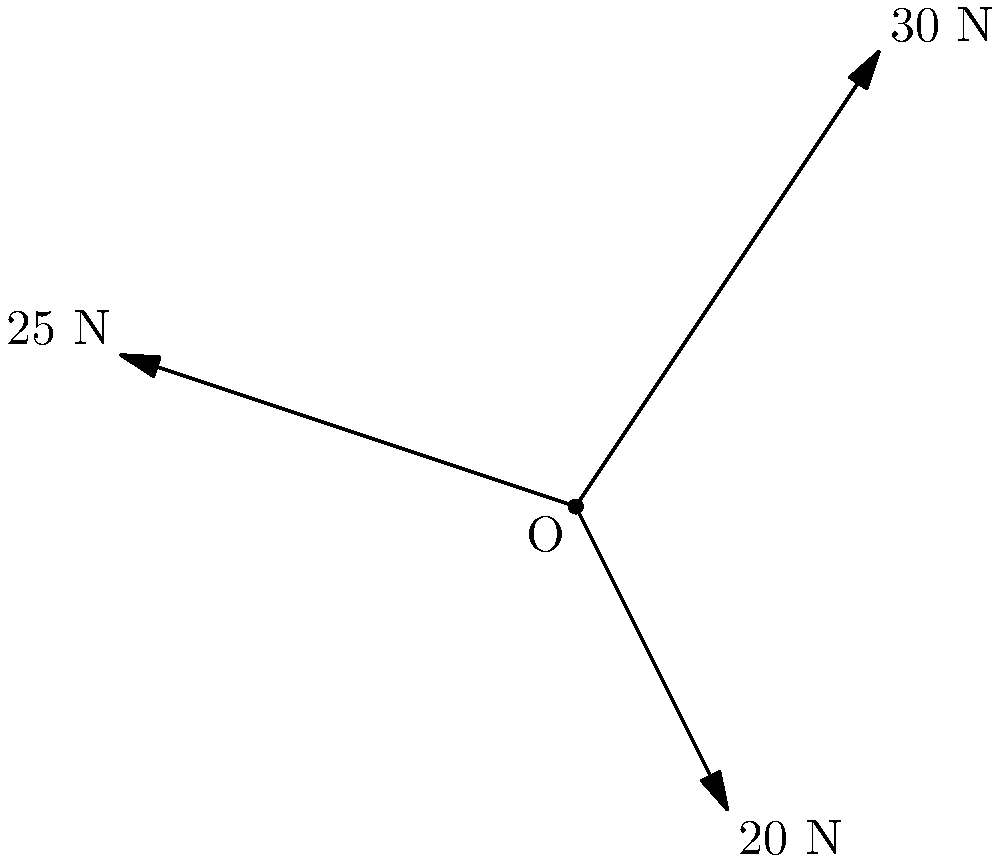Three comedians are pulling on a microphone stand with different forces as shown in the diagram. Comedian A pulls with 30 N at an angle of 56.3° from the positive x-axis, Comedian B pulls with 25 N at an angle of 161.6° from the positive x-axis, and Comedian C pulls with 20 N at an angle of 296.6° from the positive x-axis. Calculate the magnitude of the resultant force on the microphone stand. Round your answer to the nearest whole number and prepare for a punchline! Let's break this down step-by-step, just like we break down a good joke:

1) First, we need to find the x and y components of each force:

   Comedian A: 
   $F_{Ax} = 30 \cos(56.3°) = 16.67$ N
   $F_{Ay} = 30 \sin(56.3°) = 24.95$ N

   Comedian B:
   $F_{Bx} = 25 \cos(161.6°) = -23.63$ N
   $F_{By} = 25 \sin(161.6°) = 8.21$ N

   Comedian C:
   $F_{Cx} = 20 \cos(296.6°) = 8.94$ N
   $F_{Cy} = 20 \sin(296.6°) = -17.89$ N

2) Now, let's sum up all the x components and y components:

   $F_x = F_{Ax} + F_{Bx} + F_{Cx} = 16.67 - 23.63 + 8.94 = 1.98$ N
   $F_y = F_{Ay} + F_{By} + F_{Cy} = 24.95 + 8.21 - 17.89 = 15.27$ N

3) The resultant force is the vector sum of these components. We can find its magnitude using the Pythagorean theorem:

   $F_{resultant} = \sqrt{F_x^2 + F_y^2} = \sqrt{1.98^2 + 15.27^2} = 15.40$ N

4) Rounding to the nearest whole number:

   $F_{resultant} \approx 15$ N

And there you have it! The resultant force is about as strong as a comedian's punchline after a long setup.
Answer: 15 N 